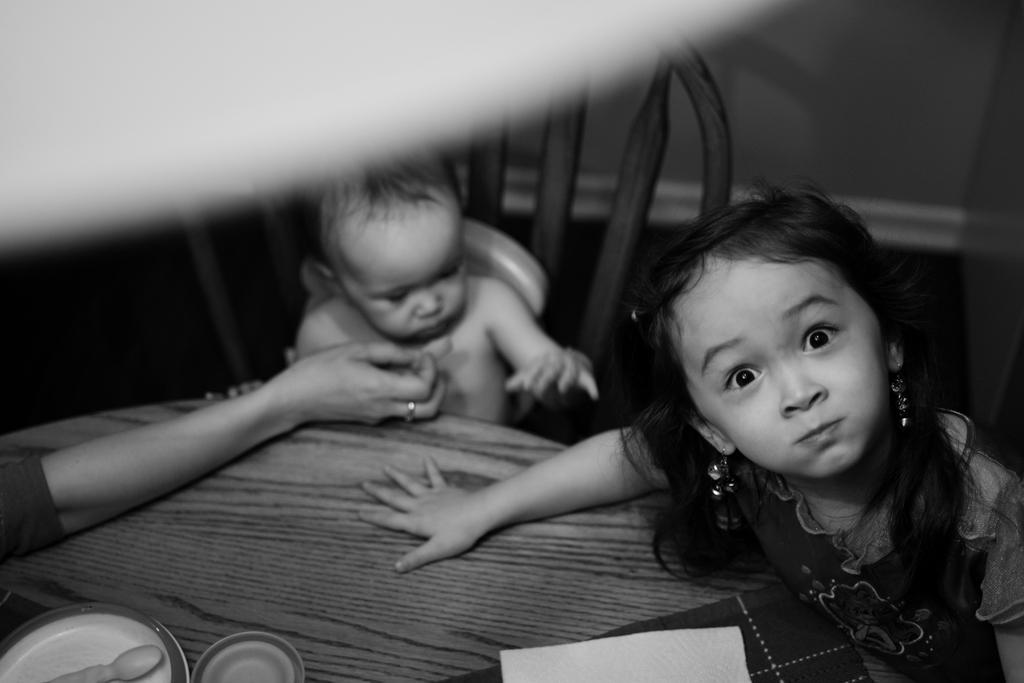Please provide a concise description of this image. In this picture we can see a child sitting on a chair, girl, cloth, plate, tissue paper, some objects and a person's hand on the table. In the background we can see the wall. 